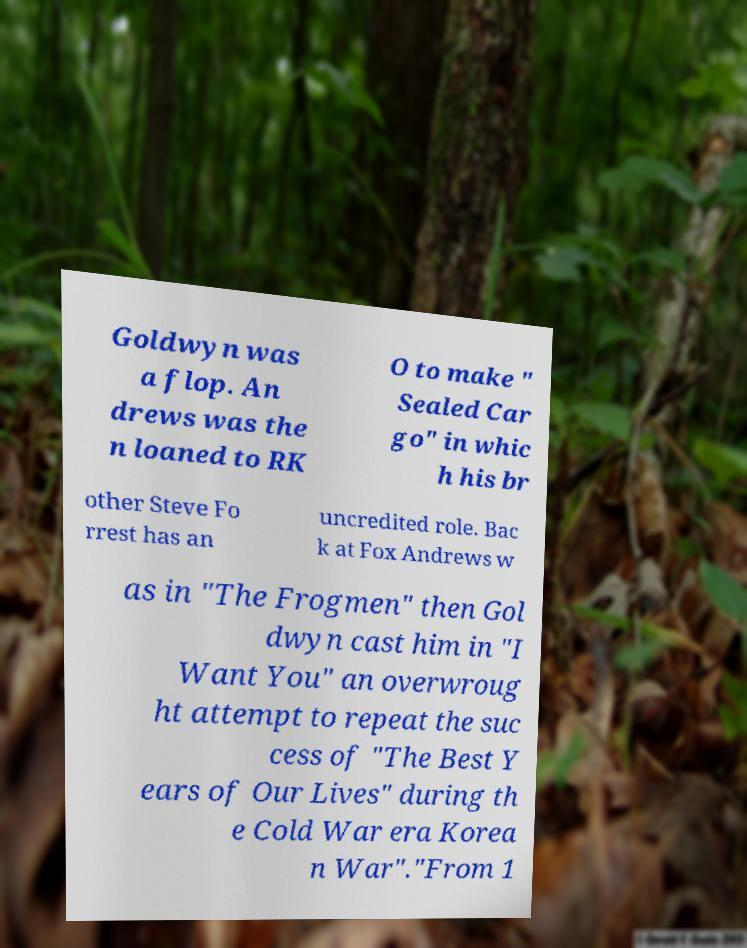Please identify and transcribe the text found in this image. Goldwyn was a flop. An drews was the n loaned to RK O to make " Sealed Car go" in whic h his br other Steve Fo rrest has an uncredited role. Bac k at Fox Andrews w as in "The Frogmen" then Gol dwyn cast him in "I Want You" an overwroug ht attempt to repeat the suc cess of "The Best Y ears of Our Lives" during th e Cold War era Korea n War"."From 1 